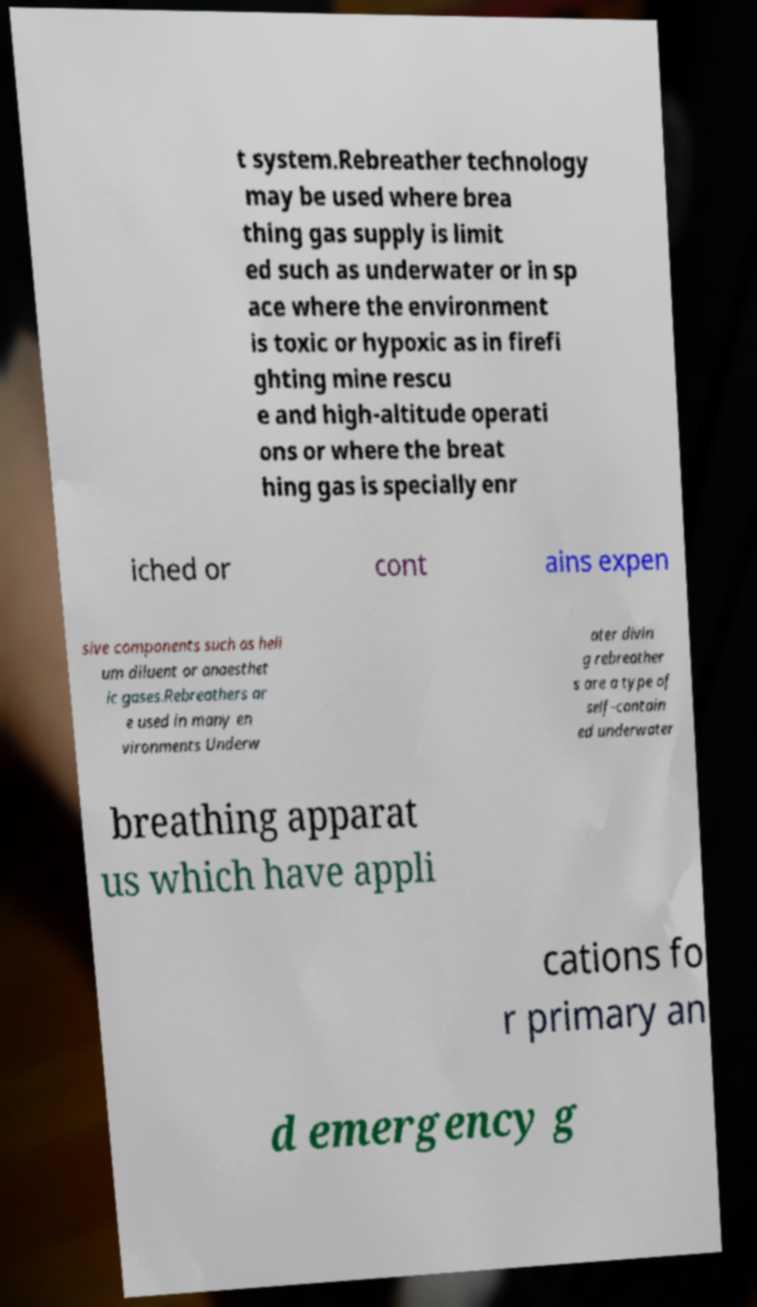I need the written content from this picture converted into text. Can you do that? t system.Rebreather technology may be used where brea thing gas supply is limit ed such as underwater or in sp ace where the environment is toxic or hypoxic as in firefi ghting mine rescu e and high-altitude operati ons or where the breat hing gas is specially enr iched or cont ains expen sive components such as heli um diluent or anaesthet ic gases.Rebreathers ar e used in many en vironments Underw ater divin g rebreather s are a type of self-contain ed underwater breathing apparat us which have appli cations fo r primary an d emergency g 